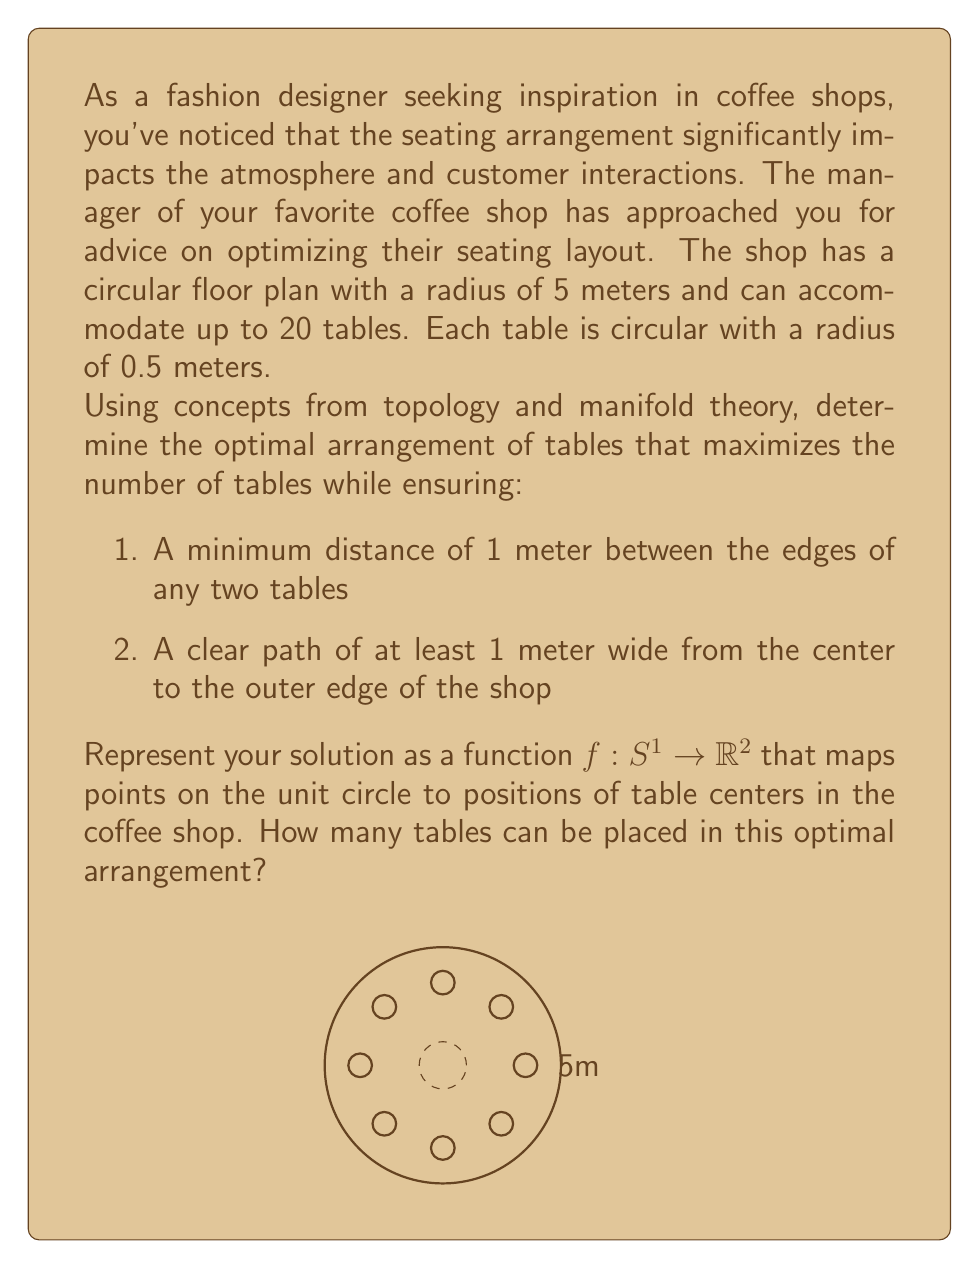Can you solve this math problem? To solve this problem, we'll use concepts from manifold theory and optimization on the 2-dimensional disk manifold. Let's approach this step-by-step:

1) First, we need to consider the constraints:
   - The shop floor is a disk with radius 5m
   - Tables have a radius of 0.5m
   - Minimum distance between table edges is 1m
   - A 1m wide path from center to edge must be maintained

2) The 1m path requirement effectively creates an inner circle with radius 1m that can't contain tables.

3) The maximum radius at which we can place table centers is:
   $$5m - 0.5m = 4.5m$$

4) The minimum radius at which we can place table centers is:
   $$1m + 0.5m = 1.5m$$

5) So, we're working with an annulus with inner radius 1.5m and outer radius 4.5m.

6) The distance between the centers of two adjacent tables should be at least:
   $$0.5m + 1m + 0.5m = 2m$$

7) We can model this as placing points on a circle, where each point represents a table center. The optimal arrangement will be evenly spaced points on this circle.

8) The circumference of a circle with radius 3m (average of 1.5m and 4.5m) is:
   $$2\pi r = 2\pi * 3m \approx 18.85m$$

9) The maximum number of tables we can fit is:
   $$\lfloor 18.85m / 2m \rfloor = 9$$

10) The function $f: S^1 \to \mathbb{R}^2$ that maps points on the unit circle to table positions can be defined as:

    $$f(\theta) = (3\cos(\theta), 3\sin(\theta))$$

    where $\theta$ is the angle in radians, and the output is in meters from the center of the shop.

11) The actual positions of the tables would be:

    $$(\text{3}\cos(\text{2}\pi k/9), \text{3}\sin(\text{2}\pi k/9))$$

    for $k = 0, 1, 2, ..., 8$

Therefore, the optimal arrangement allows for 9 tables.
Answer: 9 tables; $f(\theta) = (3\cos(\theta), 3\sin(\theta))$ 